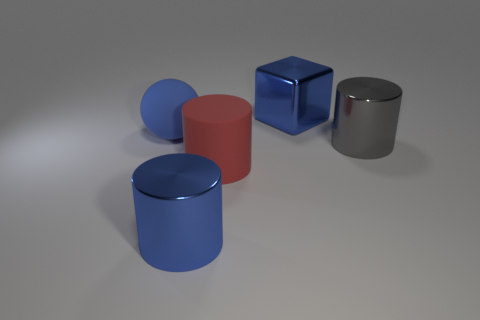Add 3 large blue spheres. How many objects exist? 8 Subtract all blocks. How many objects are left? 4 Subtract all cylinders. Subtract all tiny gray cubes. How many objects are left? 2 Add 5 large blue rubber spheres. How many large blue rubber spheres are left? 6 Add 4 big blue metallic things. How many big blue metallic things exist? 6 Subtract 0 green cylinders. How many objects are left? 5 